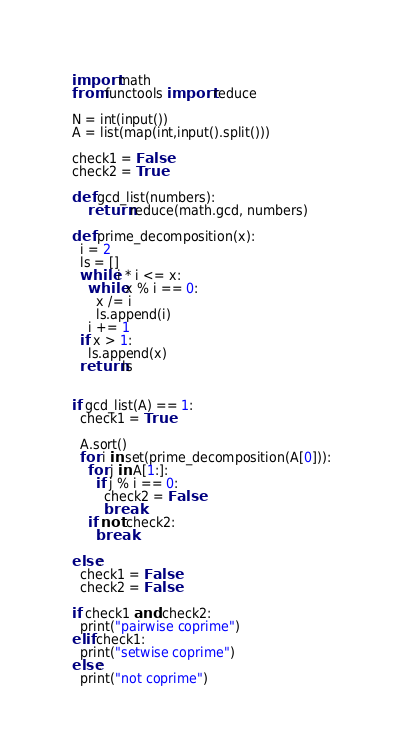Convert code to text. <code><loc_0><loc_0><loc_500><loc_500><_Python_>import math
from functools import reduce

N = int(input())
A = list(map(int,input().split()))

check1 = False
check2 = True

def gcd_list(numbers):
    return reduce(math.gcd, numbers)
  
def prime_decomposition(x):
  i = 2
  ls = []
  while i * i <= x:
    while x % i == 0:
      x /= i
      ls.append(i)
    i += 1
  if x > 1:
    ls.append(x)
  return ls
  

if gcd_list(A) == 1:
  check1 = True
  
  A.sort()
  for i in set(prime_decomposition(A[0])):
    for j in A[1:]:
      if j % i == 0:
        check2 = False
        break
    if not check2:
      break

else:
  check1 = False
  check2 = False
    
if check1 and check2:
  print("pairwise coprime")
elif check1:
  print("setwise coprime")
else:
  print("not coprime")</code> 